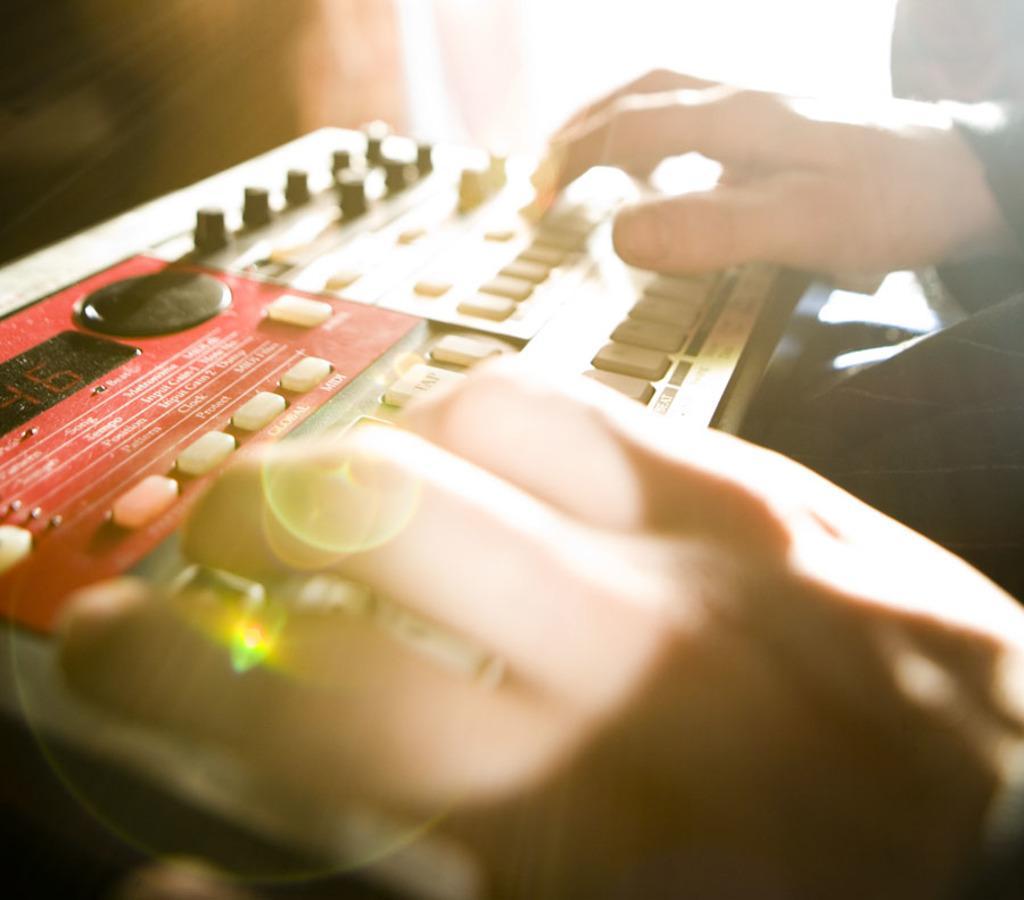Please provide a concise description of this image. On the right side, there is a person placing both hands on a device which is having buttons and a screen. And the background is blurred. 